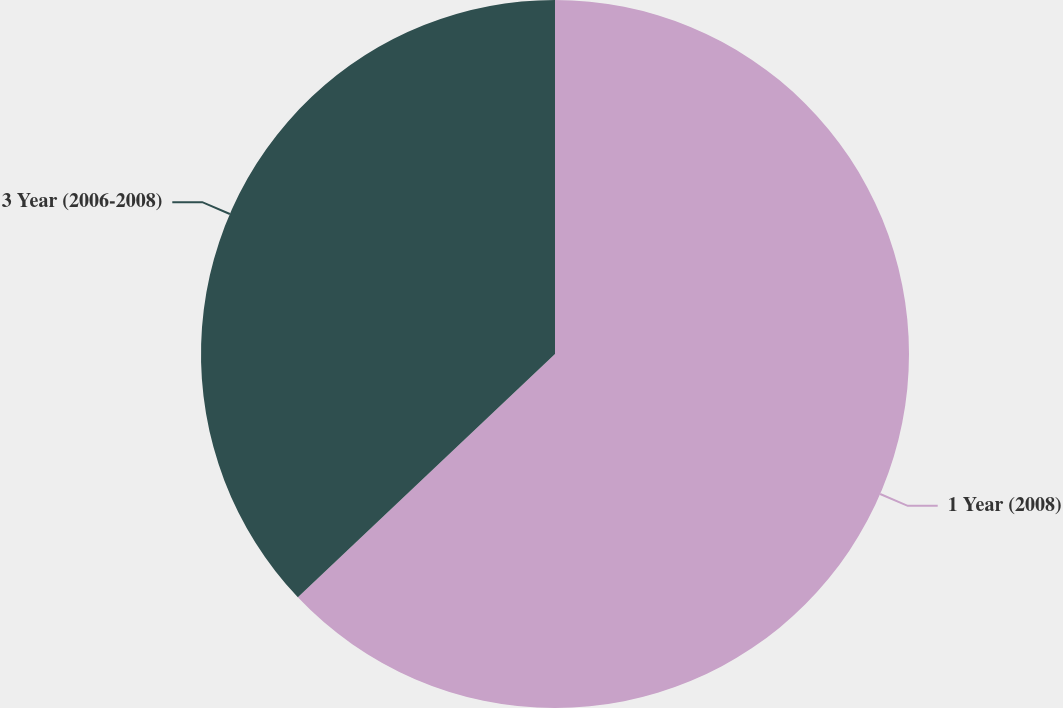Convert chart to OTSL. <chart><loc_0><loc_0><loc_500><loc_500><pie_chart><fcel>1 Year (2008)<fcel>3 Year (2006-2008)<nl><fcel>62.94%<fcel>37.06%<nl></chart> 